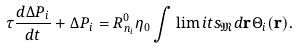<formula> <loc_0><loc_0><loc_500><loc_500>\tau \frac { d \Delta P _ { i } } { d t } + \Delta P _ { i } = R _ { n _ { i } } ^ { 0 } \eta _ { 0 } \int \lim i t s _ { \mathfrak M } d { \mathbf r } \Theta _ { i } ( { \mathbf r } ) .</formula> 